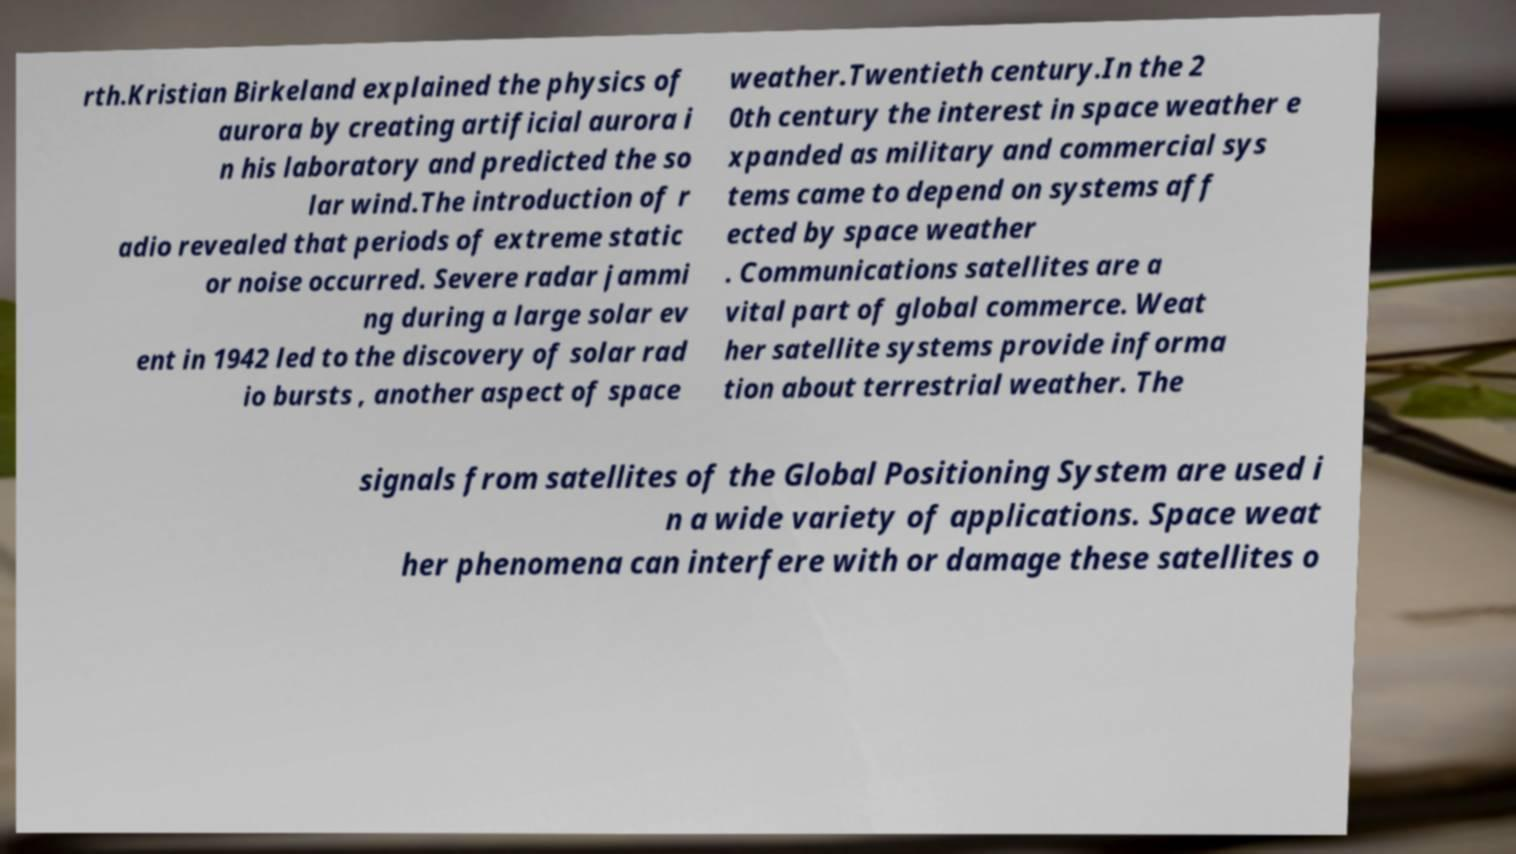For documentation purposes, I need the text within this image transcribed. Could you provide that? rth.Kristian Birkeland explained the physics of aurora by creating artificial aurora i n his laboratory and predicted the so lar wind.The introduction of r adio revealed that periods of extreme static or noise occurred. Severe radar jammi ng during a large solar ev ent in 1942 led to the discovery of solar rad io bursts , another aspect of space weather.Twentieth century.In the 2 0th century the interest in space weather e xpanded as military and commercial sys tems came to depend on systems aff ected by space weather . Communications satellites are a vital part of global commerce. Weat her satellite systems provide informa tion about terrestrial weather. The signals from satellites of the Global Positioning System are used i n a wide variety of applications. Space weat her phenomena can interfere with or damage these satellites o 